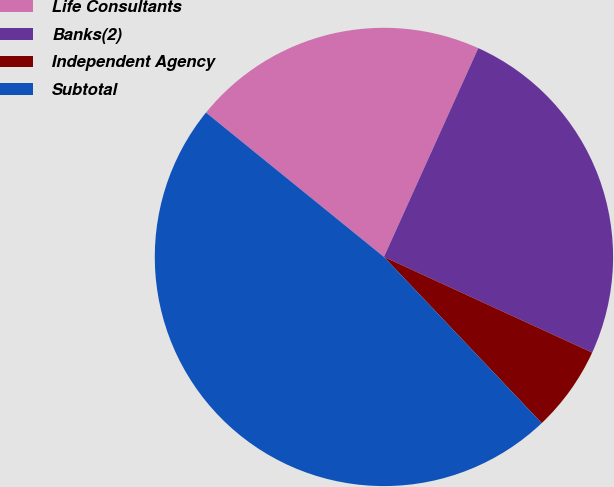Convert chart. <chart><loc_0><loc_0><loc_500><loc_500><pie_chart><fcel>Life Consultants<fcel>Banks(2)<fcel>Independent Agency<fcel>Subtotal<nl><fcel>20.91%<fcel>25.1%<fcel>6.06%<fcel>47.94%<nl></chart> 